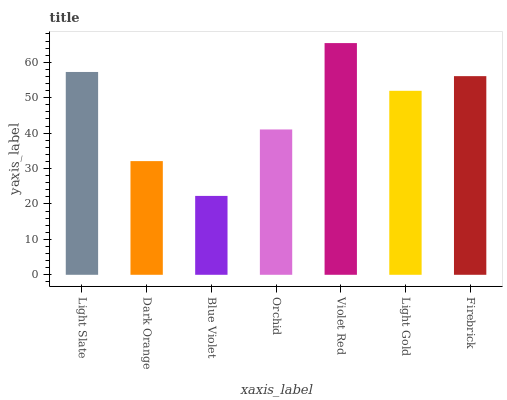Is Blue Violet the minimum?
Answer yes or no. Yes. Is Violet Red the maximum?
Answer yes or no. Yes. Is Dark Orange the minimum?
Answer yes or no. No. Is Dark Orange the maximum?
Answer yes or no. No. Is Light Slate greater than Dark Orange?
Answer yes or no. Yes. Is Dark Orange less than Light Slate?
Answer yes or no. Yes. Is Dark Orange greater than Light Slate?
Answer yes or no. No. Is Light Slate less than Dark Orange?
Answer yes or no. No. Is Light Gold the high median?
Answer yes or no. Yes. Is Light Gold the low median?
Answer yes or no. Yes. Is Orchid the high median?
Answer yes or no. No. Is Light Slate the low median?
Answer yes or no. No. 